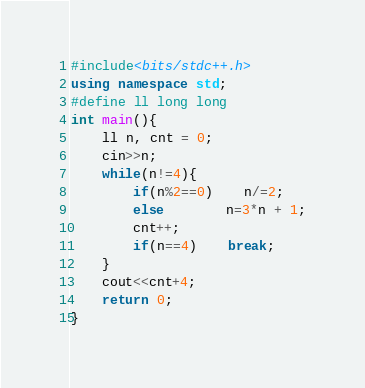Convert code to text. <code><loc_0><loc_0><loc_500><loc_500><_C++_>#include<bits/stdc++.h>
using namespace std;
#define ll long long
int main(){
	ll n, cnt = 0;
	cin>>n;
	while(n!=4){
		if(n%2==0)	n/=2;
		else		n=3*n + 1;
		cnt++;
		if(n==4)	break;
	}
	cout<<cnt+4;
	return 0;
}</code> 